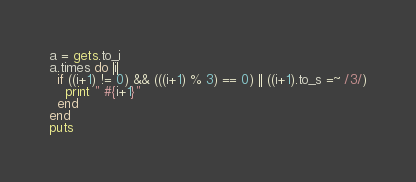Convert code to text. <code><loc_0><loc_0><loc_500><loc_500><_Ruby_>a = gets.to_i
a.times do |i|
  if ((i+1) != 0) && (((i+1) % 3) == 0) || ((i+1).to_s =~ /3/)
    print " #{i+1}"
  end
end
puts</code> 